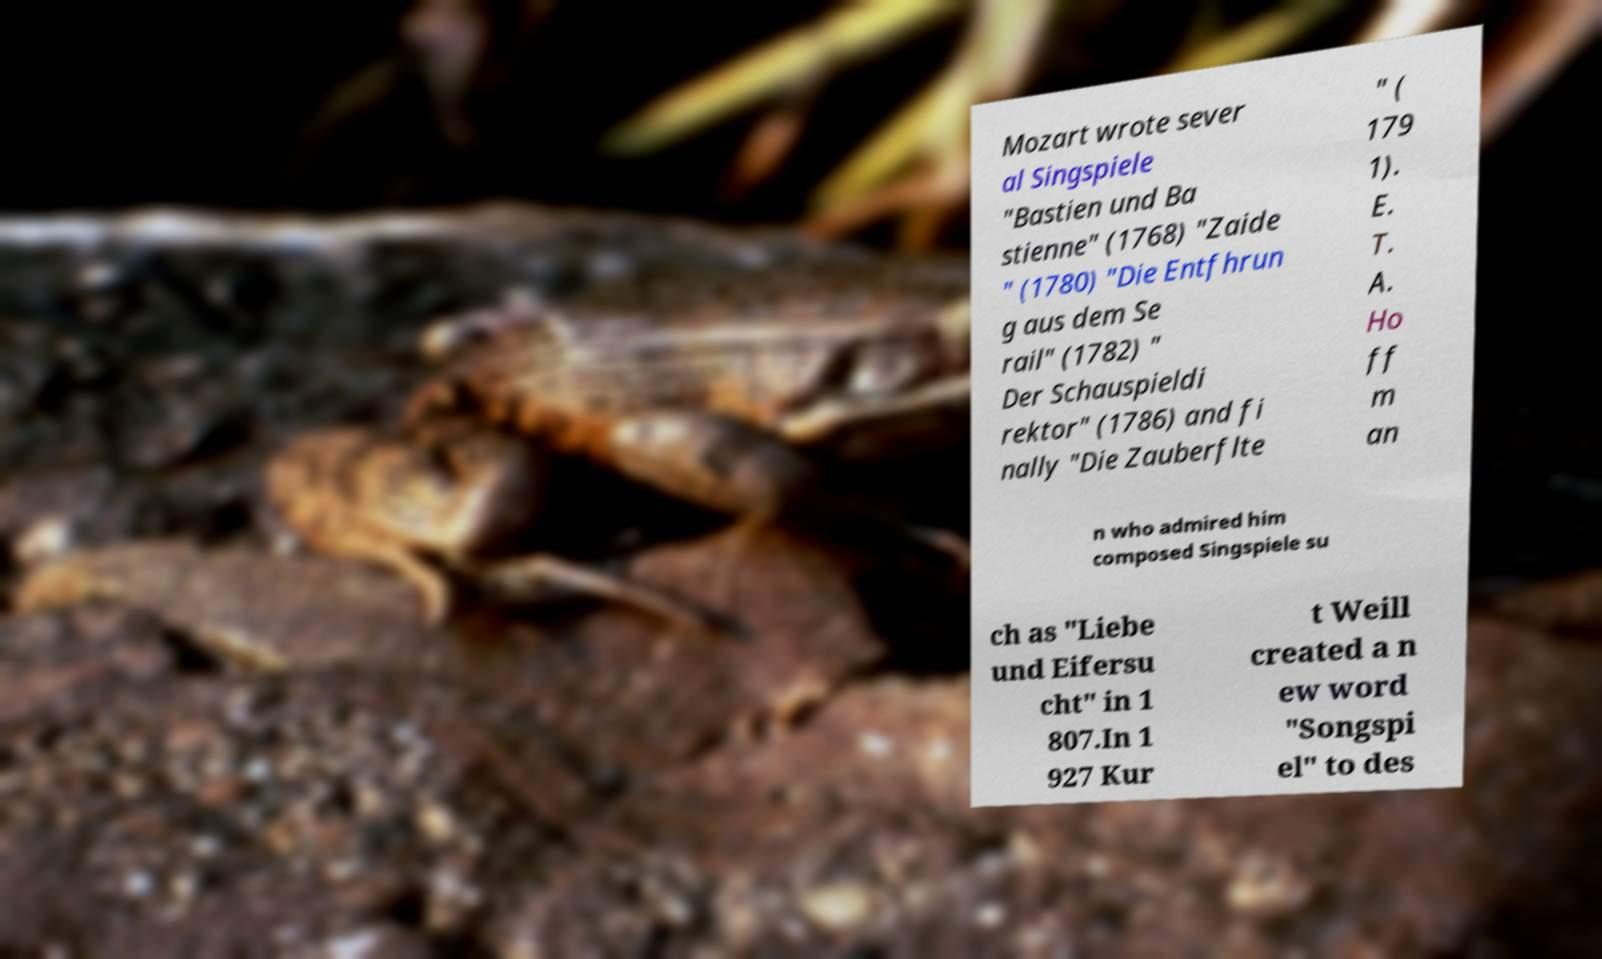There's text embedded in this image that I need extracted. Can you transcribe it verbatim? Mozart wrote sever al Singspiele "Bastien und Ba stienne" (1768) "Zaide " (1780) "Die Entfhrun g aus dem Se rail" (1782) " Der Schauspieldi rektor" (1786) and fi nally "Die Zauberflte " ( 179 1). E. T. A. Ho ff m an n who admired him composed Singspiele su ch as "Liebe und Eifersu cht" in 1 807.In 1 927 Kur t Weill created a n ew word "Songspi el" to des 